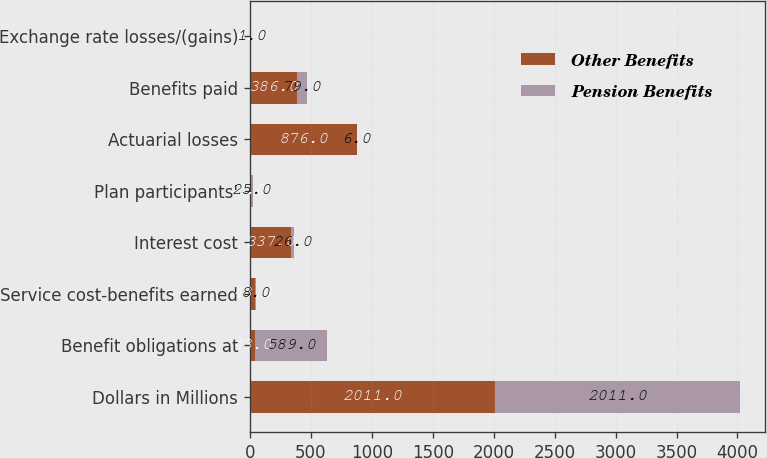Convert chart. <chart><loc_0><loc_0><loc_500><loc_500><stacked_bar_chart><ecel><fcel>Dollars in Millions<fcel>Benefit obligations at<fcel>Service cost-benefits earned<fcel>Interest cost<fcel>Plan participants'<fcel>Actuarial losses<fcel>Benefits paid<fcel>Exchange rate losses/(gains)<nl><fcel>Other Benefits<fcel>2011<fcel>43<fcel>43<fcel>337<fcel>3<fcel>876<fcel>386<fcel>6<nl><fcel>Pension Benefits<fcel>2011<fcel>589<fcel>8<fcel>26<fcel>25<fcel>6<fcel>79<fcel>1<nl></chart> 